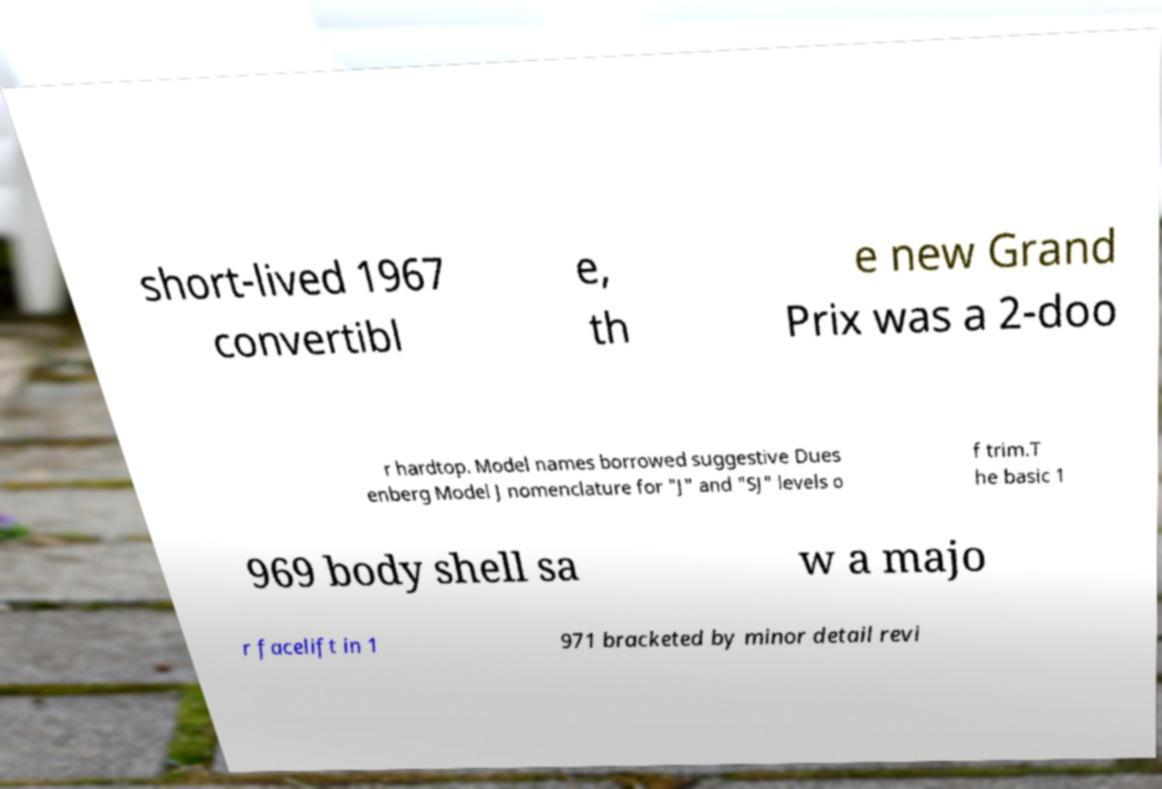Could you assist in decoding the text presented in this image and type it out clearly? short-lived 1967 convertibl e, th e new Grand Prix was a 2-doo r hardtop. Model names borrowed suggestive Dues enberg Model J nomenclature for "J" and "SJ" levels o f trim.T he basic 1 969 body shell sa w a majo r facelift in 1 971 bracketed by minor detail revi 